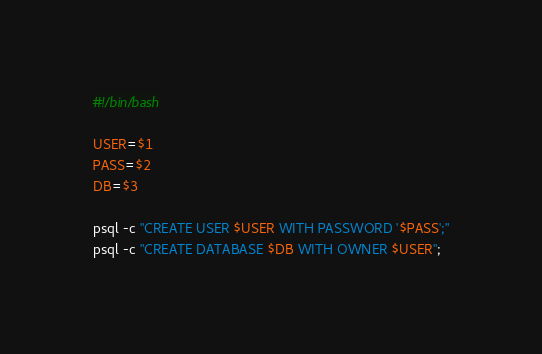<code> <loc_0><loc_0><loc_500><loc_500><_Bash_>#!/bin/bash

USER=$1
PASS=$2
DB=$3

psql -c "CREATE USER $USER WITH PASSWORD '$PASS';"
psql -c "CREATE DATABASE $DB WITH OWNER $USER";

</code> 